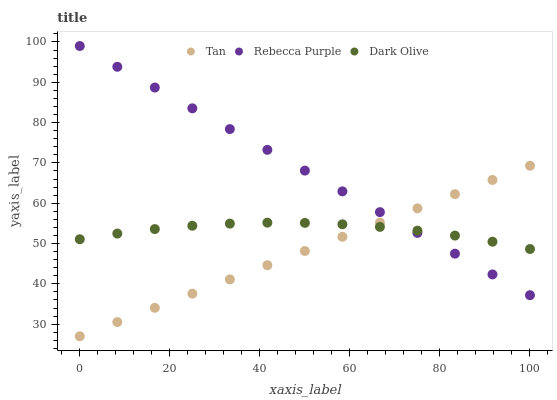Does Tan have the minimum area under the curve?
Answer yes or no. Yes. Does Rebecca Purple have the maximum area under the curve?
Answer yes or no. Yes. Does Dark Olive have the minimum area under the curve?
Answer yes or no. No. Does Dark Olive have the maximum area under the curve?
Answer yes or no. No. Is Tan the smoothest?
Answer yes or no. Yes. Is Dark Olive the roughest?
Answer yes or no. Yes. Is Rebecca Purple the smoothest?
Answer yes or no. No. Is Rebecca Purple the roughest?
Answer yes or no. No. Does Tan have the lowest value?
Answer yes or no. Yes. Does Rebecca Purple have the lowest value?
Answer yes or no. No. Does Rebecca Purple have the highest value?
Answer yes or no. Yes. Does Dark Olive have the highest value?
Answer yes or no. No. Does Tan intersect Dark Olive?
Answer yes or no. Yes. Is Tan less than Dark Olive?
Answer yes or no. No. Is Tan greater than Dark Olive?
Answer yes or no. No. 